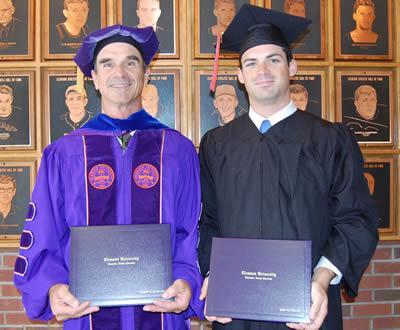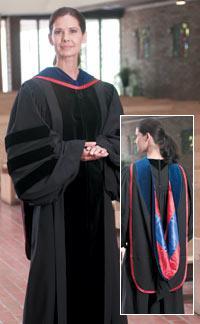The first image is the image on the left, the second image is the image on the right. Considering the images on both sides, is "One image includes at least one male in a royal blue graduation gown and cap, and the other image contains no male graduates." valid? Answer yes or no. Yes. The first image is the image on the left, the second image is the image on the right. Examine the images to the left and right. Is the description "The left image contains no more than two humans." accurate? Answer yes or no. Yes. 